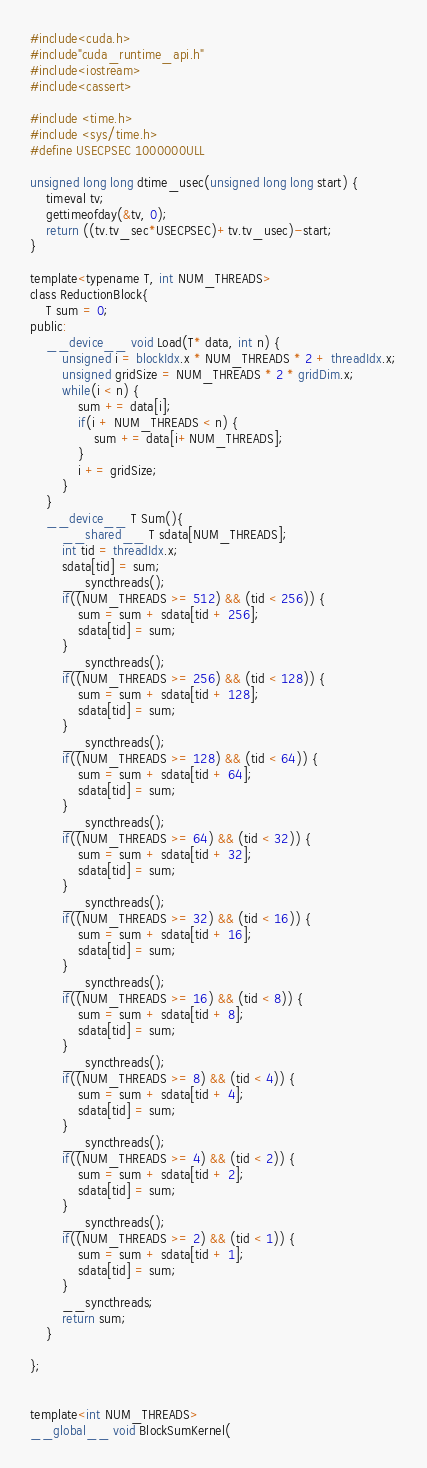Convert code to text. <code><loc_0><loc_0><loc_500><loc_500><_Cuda_>#include<cuda.h>
#include"cuda_runtime_api.h"
#include<iostream>
#include<cassert>

#include <time.h>
#include <sys/time.h>
#define USECPSEC 1000000ULL

unsigned long long dtime_usec(unsigned long long start) {
    timeval tv;
    gettimeofday(&tv, 0);
    return ((tv.tv_sec*USECPSEC)+tv.tv_usec)-start;
}

template<typename T, int NUM_THREADS>
class ReductionBlock{
    T sum = 0;
public:
    __device__ void Load(T* data, int n) {
        unsigned i = blockIdx.x * NUM_THREADS * 2 + threadIdx.x;
        unsigned gridSize = NUM_THREADS * 2 * gridDim.x;
        while(i < n) {
            sum += data[i];
            if(i + NUM_THREADS < n) {
                sum += data[i+NUM_THREADS];
            }
            i += gridSize;
        }
    }
    __device__ T Sum(){
        __shared__ T sdata[NUM_THREADS];
        int tid = threadIdx.x;
        sdata[tid] = sum;
        __syncthreads();
        if((NUM_THREADS >= 512) && (tid < 256)) {
            sum = sum + sdata[tid + 256];
            sdata[tid] = sum;
        }
        __syncthreads();
        if((NUM_THREADS >= 256) && (tid < 128)) {
            sum = sum + sdata[tid + 128];
            sdata[tid] = sum;
        }
        __syncthreads();
        if((NUM_THREADS >= 128) && (tid < 64)) {
            sum = sum + sdata[tid + 64];
            sdata[tid] = sum;
        }
        __syncthreads();
        if((NUM_THREADS >= 64) && (tid < 32)) {
            sum = sum + sdata[tid + 32];
            sdata[tid] = sum;
        }
        __syncthreads();
        if((NUM_THREADS >= 32) && (tid < 16)) {
            sum = sum + sdata[tid + 16];
            sdata[tid] = sum;
        }
        __syncthreads();
        if((NUM_THREADS >= 16) && (tid < 8)) {
            sum = sum + sdata[tid + 8];
            sdata[tid] = sum;
        }
        __syncthreads();
        if((NUM_THREADS >= 8) && (tid < 4)) {
            sum = sum + sdata[tid + 4];
            sdata[tid] = sum;
        }
        __syncthreads();
        if((NUM_THREADS >= 4) && (tid < 2)) {
            sum = sum + sdata[tid + 2];
            sdata[tid] = sum;
        }
        __syncthreads();
        if((NUM_THREADS >= 2) && (tid < 1)) {
            sum = sum + sdata[tid + 1];
            sdata[tid] = sum;
        }
        __syncthreads;
        return sum;
    }

};


template<int NUM_THREADS>
__global__ void BlockSumKernel(</code> 